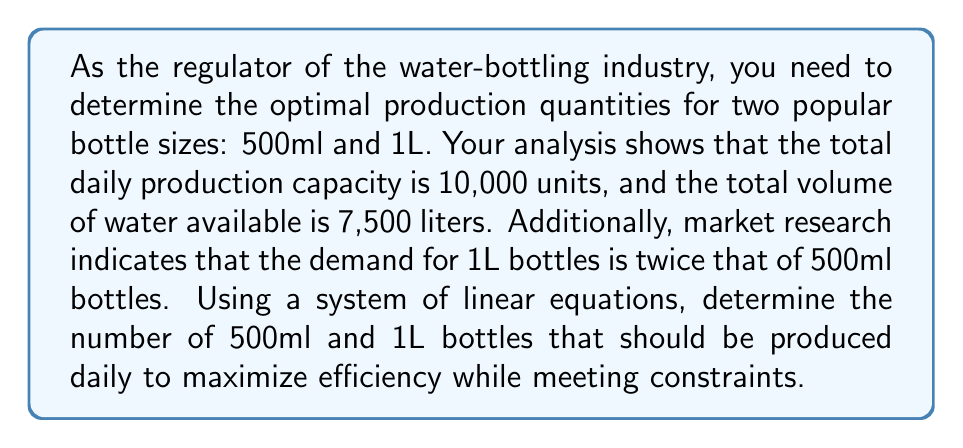Show me your answer to this math problem. Let's approach this step-by-step using a system of linear equations:

1) Let $x$ be the number of 500ml bottles and $y$ be the number of 1L bottles.

2) We can form three equations based on the given information:

   a) Total production constraint: 
      $$x + y = 10000$$

   b) Total volume constraint:
      $$0.5x + 1y = 7500$$

   c) Demand relationship:
      $$y = 2x$$

3) We now have a system of three equations with two unknowns:

   $$\begin{cases}
   x + y = 10000 \\
   0.5x + y = 7500 \\
   y = 2x
   \end{cases}$$

4) Let's solve this system by substitution. Using the third equation, substitute $y = 2x$ into the first two equations:

   $$\begin{cases}
   x + 2x = 10000 \\
   0.5x + 2x = 7500
   \end{cases}$$

5) Simplify:

   $$\begin{cases}
   3x = 10000 \\
   2.5x = 7500
   \end{cases}$$

6) From the first equation:
   $$x = \frac{10000}{3} \approx 3333.33$$

7) From the second equation:
   $$x = \frac{7500}{2.5} = 3000$$

8) The solution that satisfies both equations is $x = 3000$.

9) Substituting this back into $y = 2x$:
   $$y = 2(3000) = 6000$$

Therefore, the optimal production quantities are 3000 500ml bottles and 6000 1L bottles.

Let's verify that this solution meets all constraints:
- Total production: $3000 + 6000 = 9000$ ≤ 10000
- Total volume: $0.5(3000) + 1(6000) = 7500$ liters
- Demand relationship: $6000 = 2(3000)$

All constraints are satisfied.
Answer: The optimal daily production quantities are 3000 500ml bottles and 6000 1L bottles. 